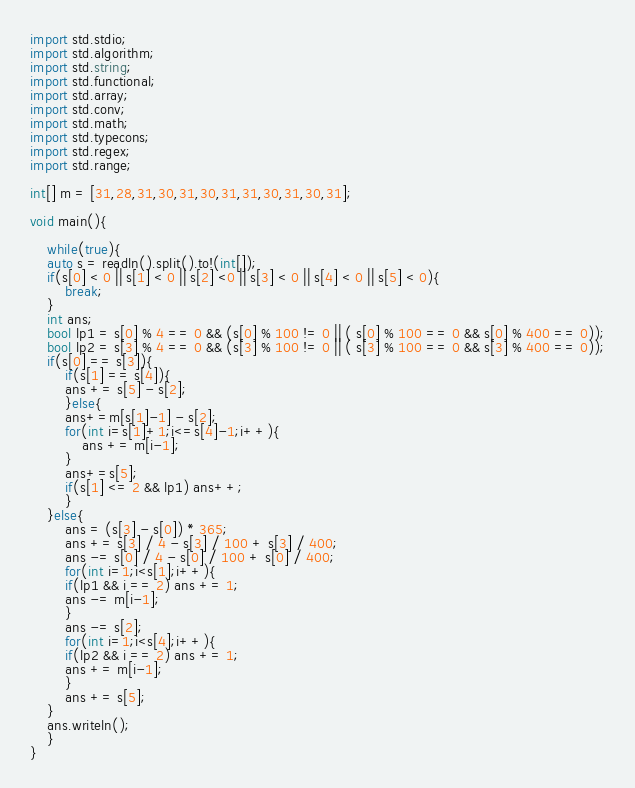Convert code to text. <code><loc_0><loc_0><loc_500><loc_500><_D_>import std.stdio;
import std.algorithm;
import std.string;
import std.functional;
import std.array;
import std.conv;
import std.math;
import std.typecons;
import std.regex;
import std.range;

int[] m = [31,28,31,30,31,30,31,31,30,31,30,31];

void main(){

    while(true){
	auto s = readln().split().to!(int[]);
	if(s[0] < 0 || s[1] < 0 || s[2] <0 || s[3] < 0 || s[4] < 0 || s[5] < 0){
	    break;
	}
	int ans;
	bool lp1 = s[0] % 4 == 0 && (s[0] % 100 != 0 || ( s[0] % 100 == 0 && s[0] % 400 == 0));
	bool lp2 = s[3] % 4 == 0 && (s[3] % 100 != 0 || ( s[3] % 100 == 0 && s[3] % 400 == 0));
	if(s[0] == s[3]){
	    if(s[1] == s[4]){
		ans += s[5] - s[2];
	    }else{
		ans+=m[s[1]-1] - s[2];
		for(int i=s[1]+1;i<=s[4]-1;i++){
		    ans += m[i-1];
		}
		ans+=s[5];
		if(s[1] <= 2 && lp1) ans++;
	    }
	}else{
	    ans = (s[3] - s[0]) * 365;
	    ans += s[3] / 4 - s[3] / 100 + s[3] / 400;
	    ans -= s[0] / 4 - s[0] / 100 + s[0] / 400;
	    for(int i=1;i<s[1];i++){
		if(lp1 && i == 2) ans += 1;
		ans -= m[i-1];
	    }
	    ans -= s[2];
	    for(int i=1;i<s[4];i++){
		if(lp2 && i == 2) ans += 1;
		ans += m[i-1];
	    }
	    ans += s[5];
	}
	ans.writeln();
    }
}</code> 